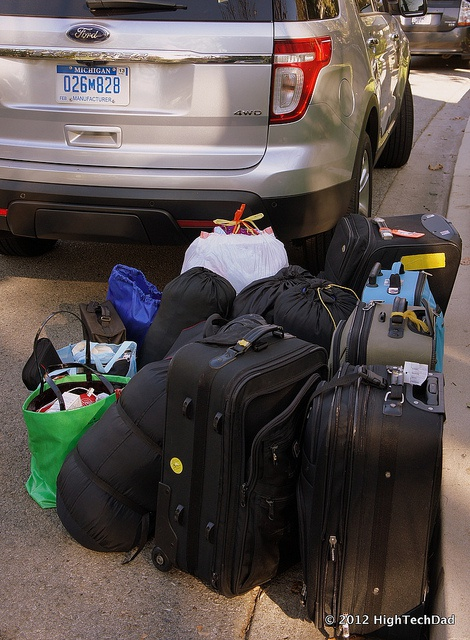Describe the objects in this image and their specific colors. I can see car in purple, black, darkgray, gray, and lightgray tones, suitcase in purple, black, gray, and maroon tones, suitcase in purple, black, and gray tones, suitcase in purple, black, gray, and darkgray tones, and suitcase in purple, gray, and black tones in this image. 